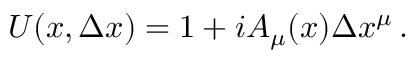<formula> <loc_0><loc_0><loc_500><loc_500>U ( x , \Delta x ) = 1 + i A _ { \mu } ( x ) \Delta x ^ { \mu } \, .</formula> 